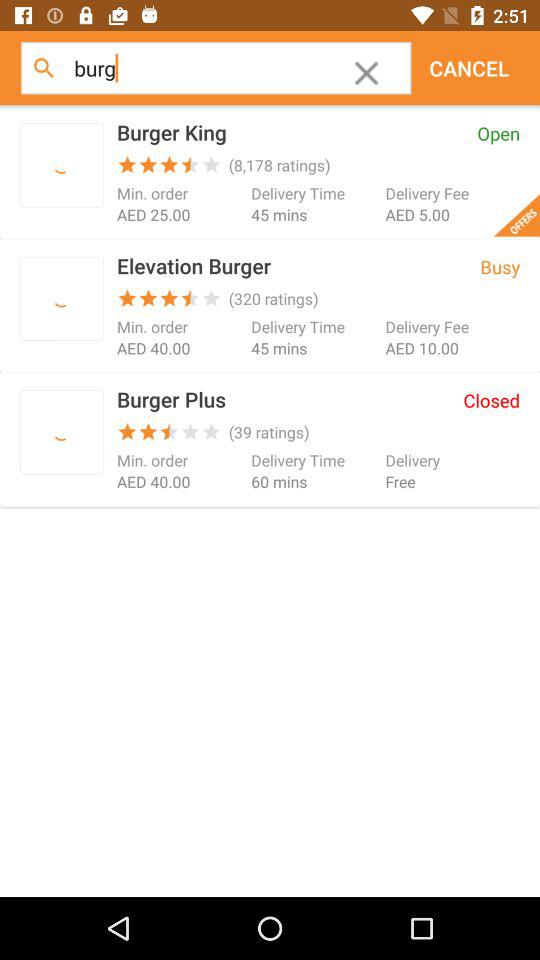What is the rating for "Burger King"? The rating is 3.5 stars. 